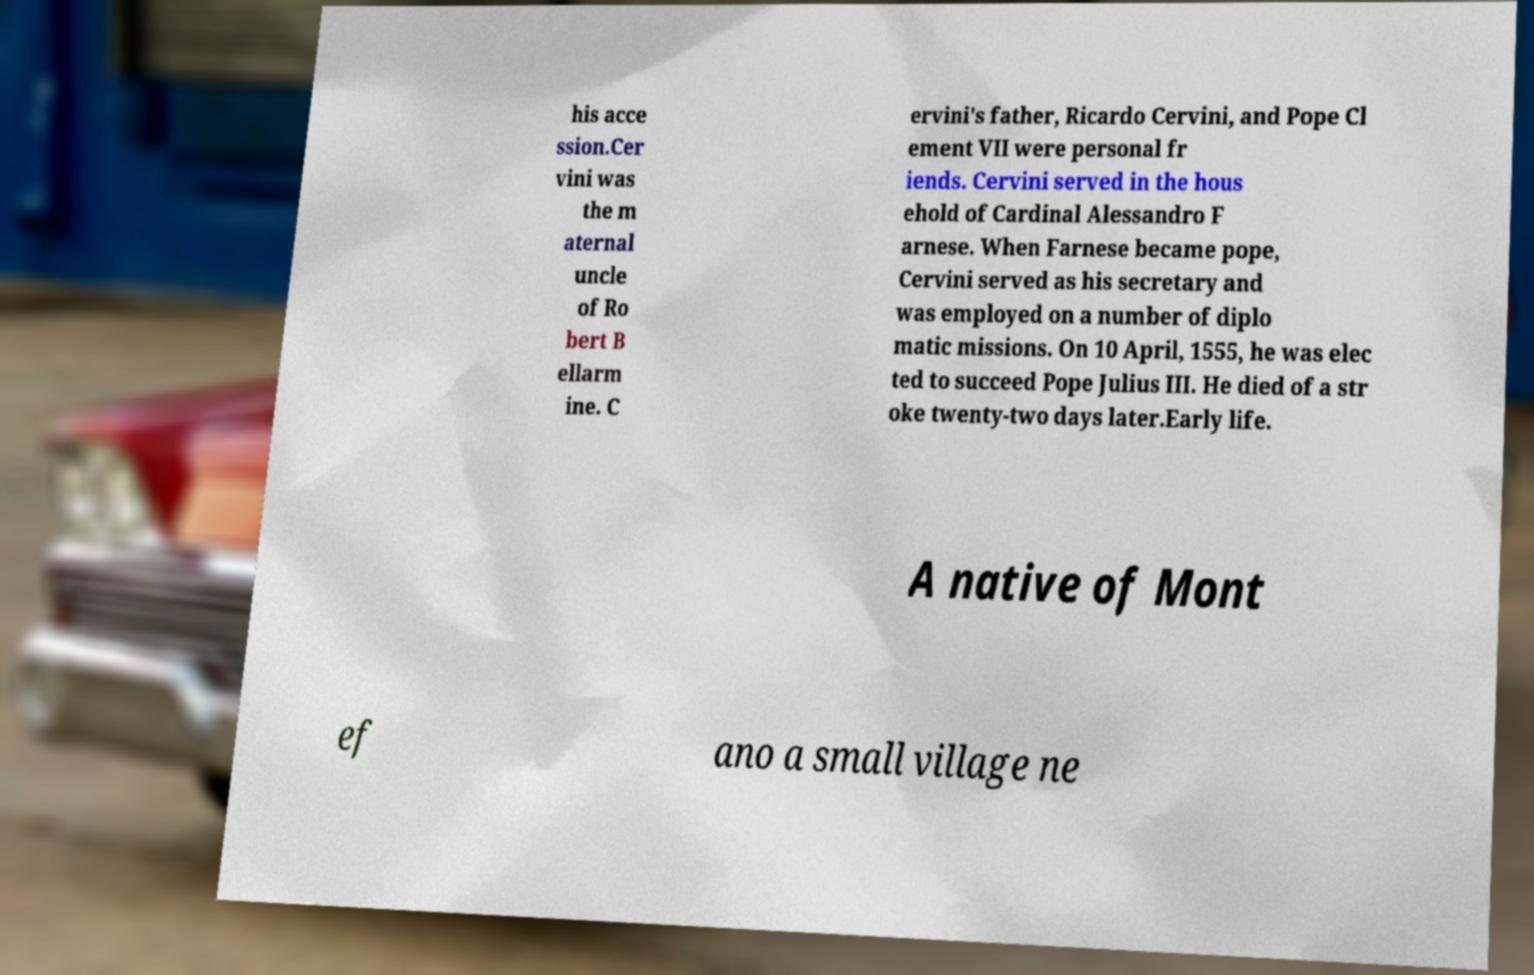Could you extract and type out the text from this image? his acce ssion.Cer vini was the m aternal uncle of Ro bert B ellarm ine. C ervini's father, Ricardo Cervini, and Pope Cl ement VII were personal fr iends. Cervini served in the hous ehold of Cardinal Alessandro F arnese. When Farnese became pope, Cervini served as his secretary and was employed on a number of diplo matic missions. On 10 April, 1555, he was elec ted to succeed Pope Julius III. He died of a str oke twenty-two days later.Early life. A native of Mont ef ano a small village ne 